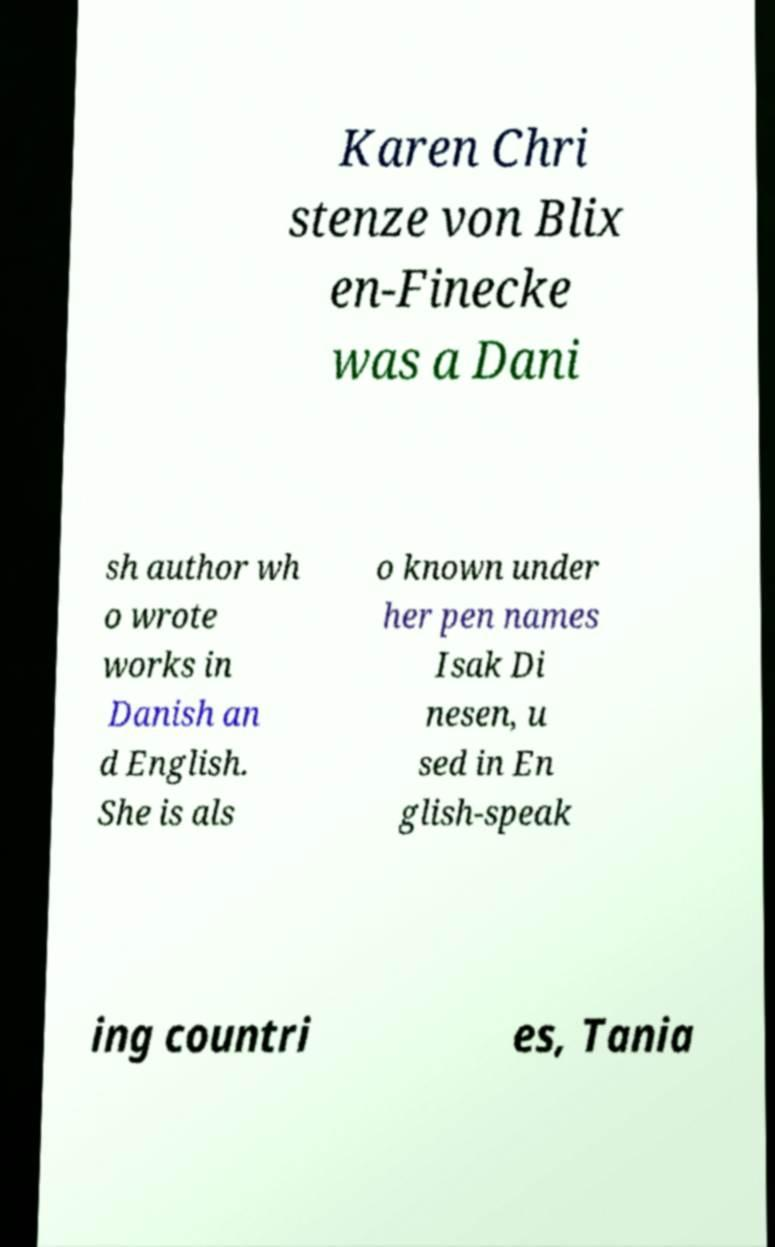For documentation purposes, I need the text within this image transcribed. Could you provide that? Karen Chri stenze von Blix en-Finecke was a Dani sh author wh o wrote works in Danish an d English. She is als o known under her pen names Isak Di nesen, u sed in En glish-speak ing countri es, Tania 